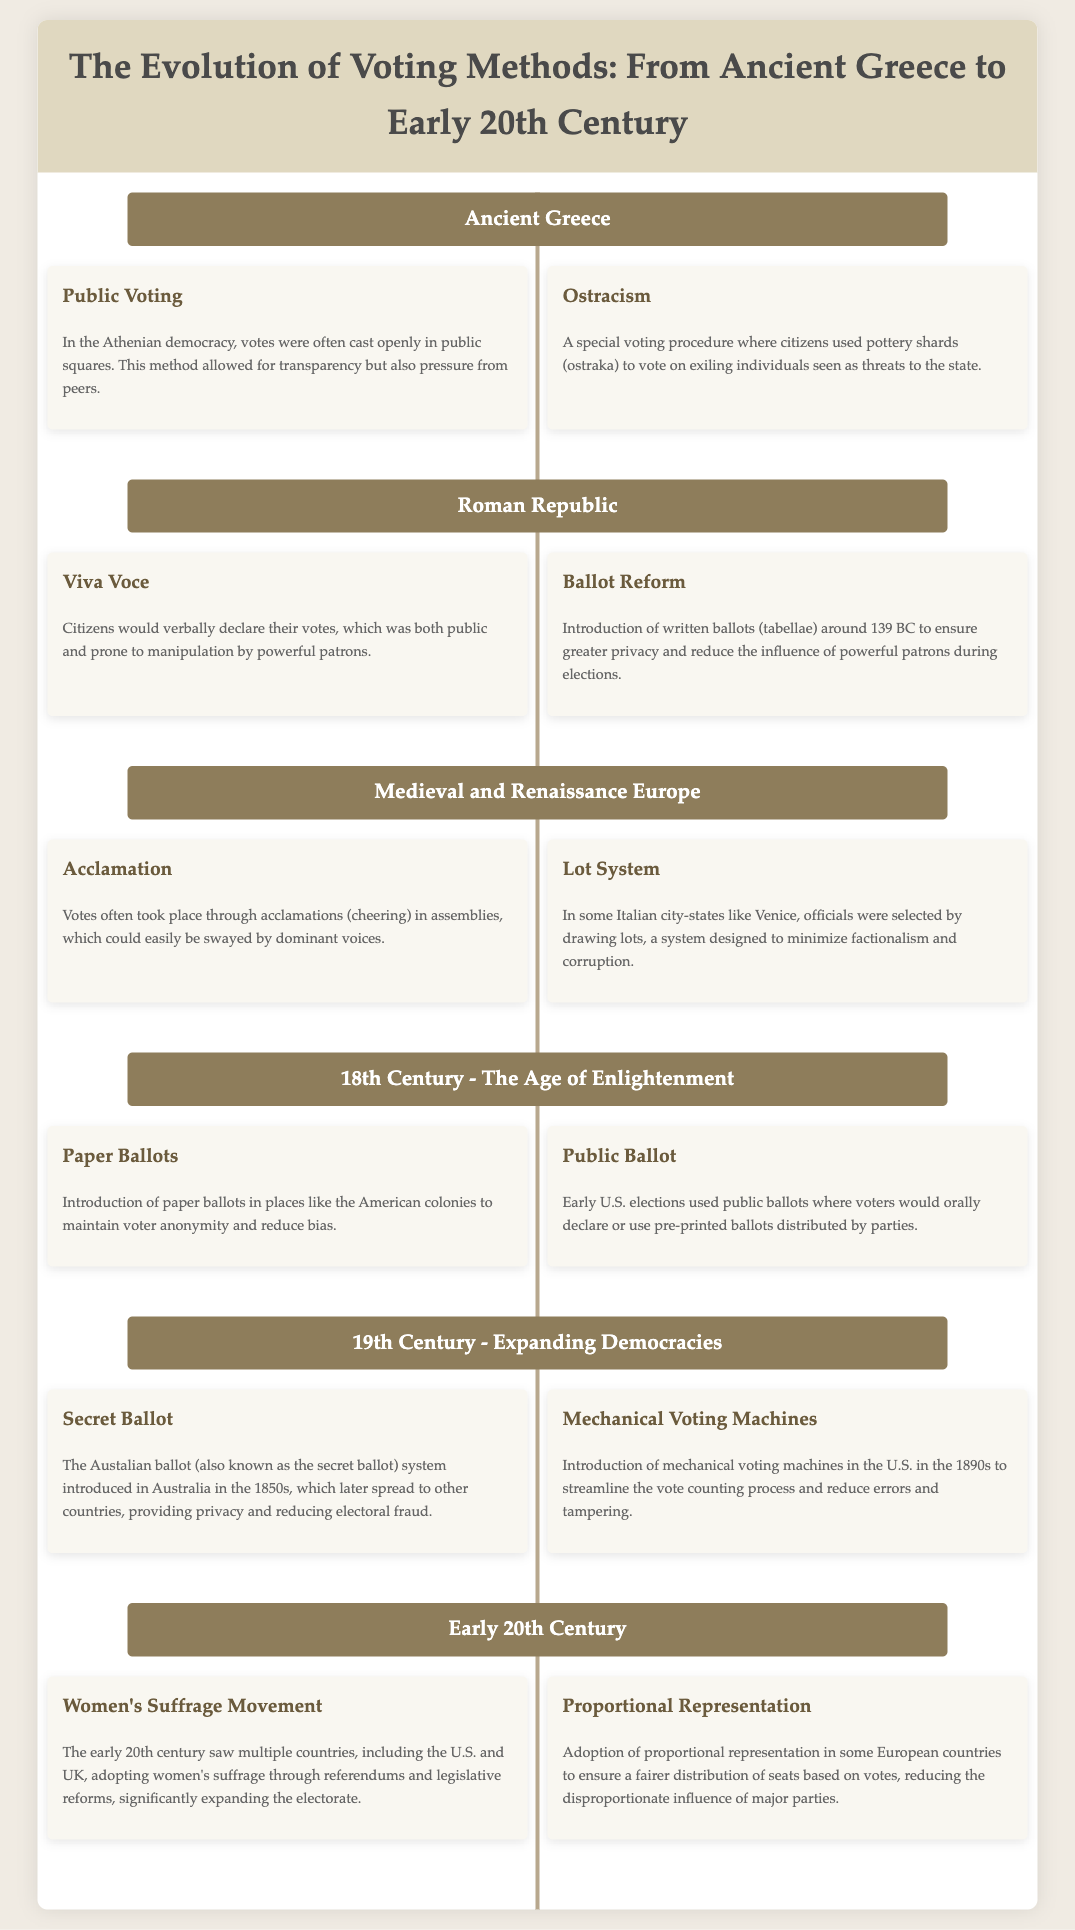what voting method allowed citizens to verbally declare their votes in the Roman Republic? The document states that citizens would verbally declare their votes, known as "Viva Voce."
Answer: Viva Voce which voting system introduced around 1850s provided privacy and reduced electoral fraud? The document refers to the Australian ballot system as the voting method that introduced privacy and reduced electoral fraud.
Answer: Secret Ballot what materials were used for voting in the ostracism process in Ancient Greece? The document specifically mentions that pottery shards, known as ostraka, were used for voting in ostracism.
Answer: Pottery shards which voting method used pre-printed ballots distributed by parties in early U.S. elections? The document identifies that early U.S. elections used public ballots where voters would orally declare or use pre-printed ballots.
Answer: Public Ballot what election reform significantly expanded the electorate in the early 20th century? The document notes that women's suffrage movement significantly expanded the electorate through referendums and legislative reforms.
Answer: Women's Suffrage Movement what was the main intention behind the Lot System used in some Italian city-states? The Lot System was designed to minimize factionalism and corruption in the selection of officials.
Answer: Minimize factionalism and corruption how did the introduction of paper ballots in the 18th century modify voting practices? The document suggests that the introduction of paper ballots maintained voter anonymity and reduced bias.
Answer: Maintain voter anonymity what geographical region did the mechanical voting machines first appear in the 1890s? The document indicates that mechanical voting machines were introduced in the U.S. during the 1890s.
Answer: U.S 